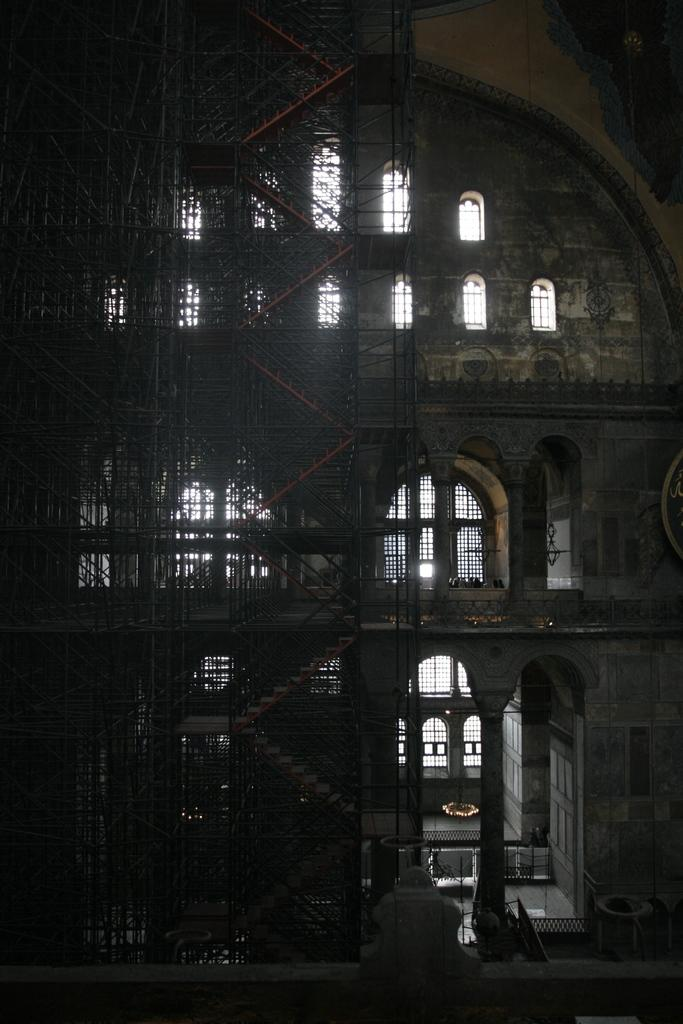What type of structure is present in the image? There is a building in the picture. What feature can be seen on the building? The building has windows. What type of security feature is present in the image? There are iron grilles in the picture. What architectural element is visible in the image? There are stairs in the picture. What type of magic is being performed in the picture? There is no magic or any indication of a magical performance in the image. 